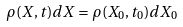<formula> <loc_0><loc_0><loc_500><loc_500>\rho ( X , t ) d X = \rho ( X _ { 0 } , t _ { 0 } ) d X _ { 0 }</formula> 